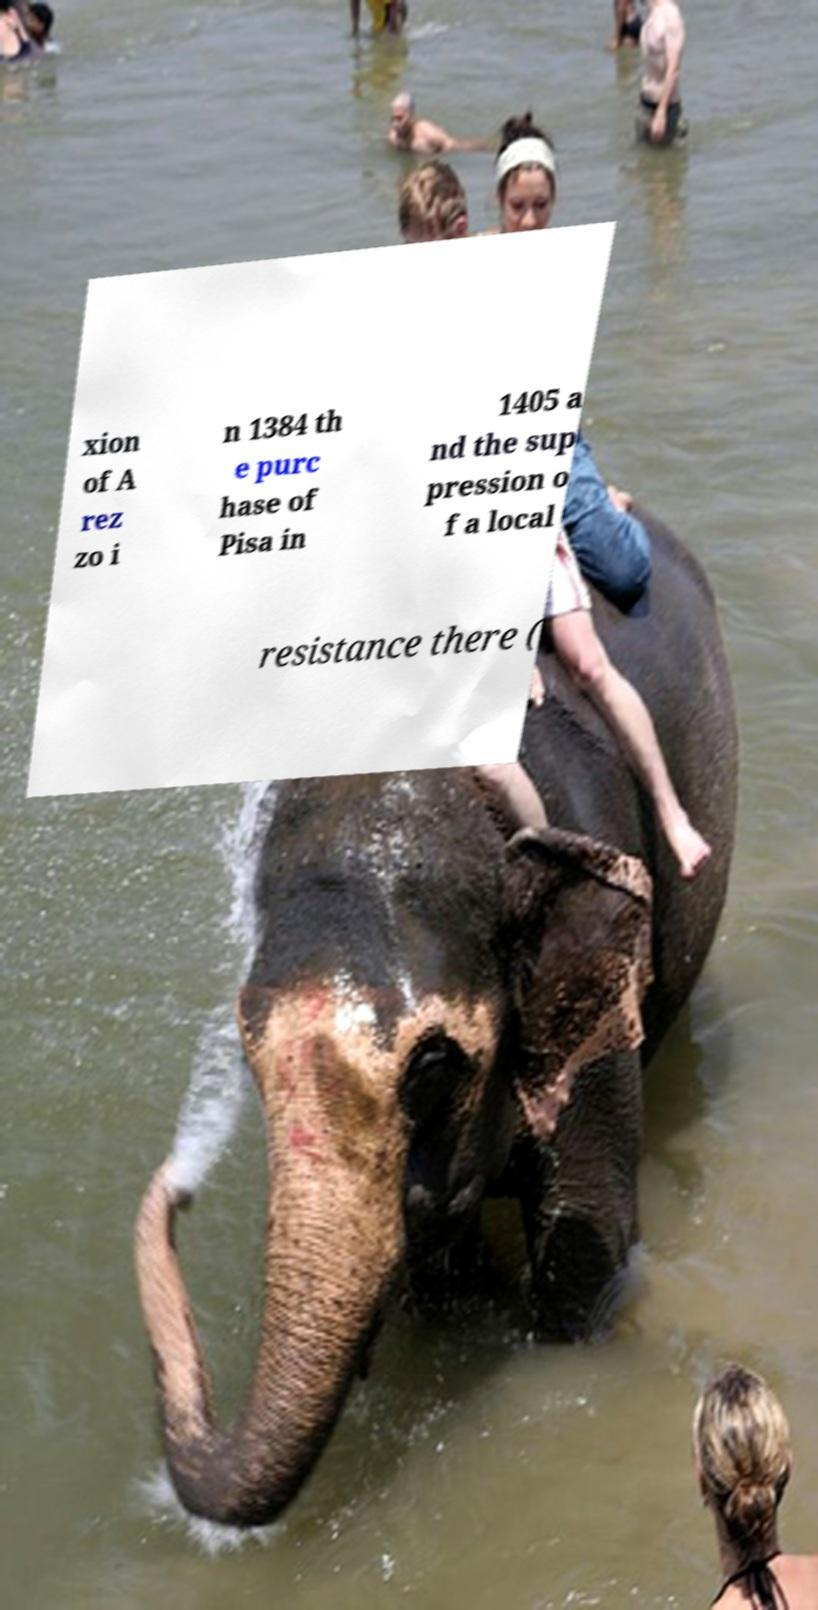For documentation purposes, I need the text within this image transcribed. Could you provide that? xion of A rez zo i n 1384 th e purc hase of Pisa in 1405 a nd the sup pression o f a local resistance there ( 